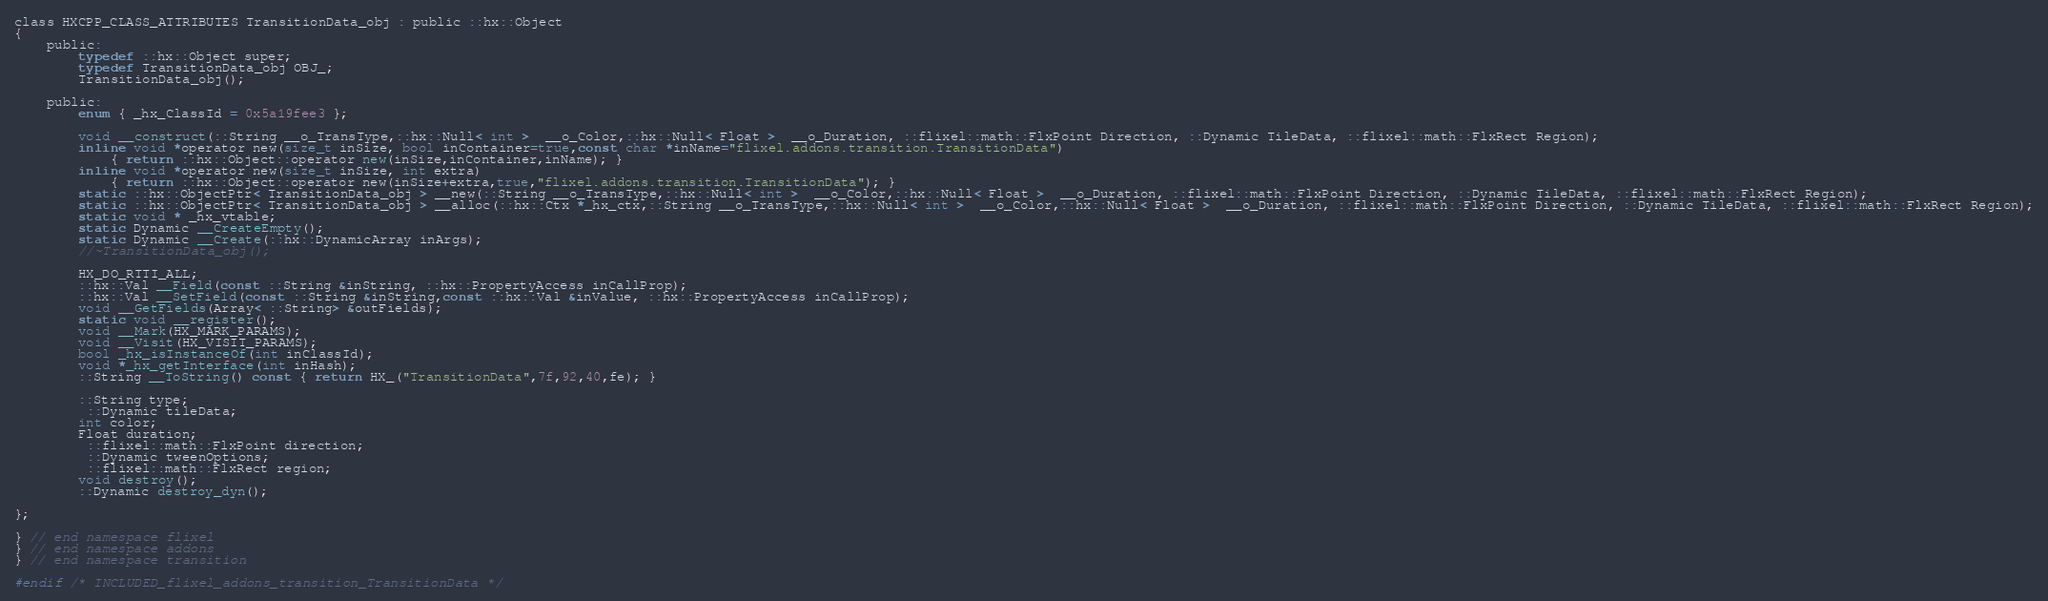Convert code to text. <code><loc_0><loc_0><loc_500><loc_500><_C_>
class HXCPP_CLASS_ATTRIBUTES TransitionData_obj : public ::hx::Object
{
	public:
		typedef ::hx::Object super;
		typedef TransitionData_obj OBJ_;
		TransitionData_obj();

	public:
		enum { _hx_ClassId = 0x5a19fee3 };

		void __construct(::String __o_TransType,::hx::Null< int >  __o_Color,::hx::Null< Float >  __o_Duration, ::flixel::math::FlxPoint Direction, ::Dynamic TileData, ::flixel::math::FlxRect Region);
		inline void *operator new(size_t inSize, bool inContainer=true,const char *inName="flixel.addons.transition.TransitionData")
			{ return ::hx::Object::operator new(inSize,inContainer,inName); }
		inline void *operator new(size_t inSize, int extra)
			{ return ::hx::Object::operator new(inSize+extra,true,"flixel.addons.transition.TransitionData"); }
		static ::hx::ObjectPtr< TransitionData_obj > __new(::String __o_TransType,::hx::Null< int >  __o_Color,::hx::Null< Float >  __o_Duration, ::flixel::math::FlxPoint Direction, ::Dynamic TileData, ::flixel::math::FlxRect Region);
		static ::hx::ObjectPtr< TransitionData_obj > __alloc(::hx::Ctx *_hx_ctx,::String __o_TransType,::hx::Null< int >  __o_Color,::hx::Null< Float >  __o_Duration, ::flixel::math::FlxPoint Direction, ::Dynamic TileData, ::flixel::math::FlxRect Region);
		static void * _hx_vtable;
		static Dynamic __CreateEmpty();
		static Dynamic __Create(::hx::DynamicArray inArgs);
		//~TransitionData_obj();

		HX_DO_RTTI_ALL;
		::hx::Val __Field(const ::String &inString, ::hx::PropertyAccess inCallProp);
		::hx::Val __SetField(const ::String &inString,const ::hx::Val &inValue, ::hx::PropertyAccess inCallProp);
		void __GetFields(Array< ::String> &outFields);
		static void __register();
		void __Mark(HX_MARK_PARAMS);
		void __Visit(HX_VISIT_PARAMS);
		bool _hx_isInstanceOf(int inClassId);
		void *_hx_getInterface(int inHash);
		::String __ToString() const { return HX_("TransitionData",7f,92,40,fe); }

		::String type;
		 ::Dynamic tileData;
		int color;
		Float duration;
		 ::flixel::math::FlxPoint direction;
		 ::Dynamic tweenOptions;
		 ::flixel::math::FlxRect region;
		void destroy();
		::Dynamic destroy_dyn();

};

} // end namespace flixel
} // end namespace addons
} // end namespace transition

#endif /* INCLUDED_flixel_addons_transition_TransitionData */ 
</code> 